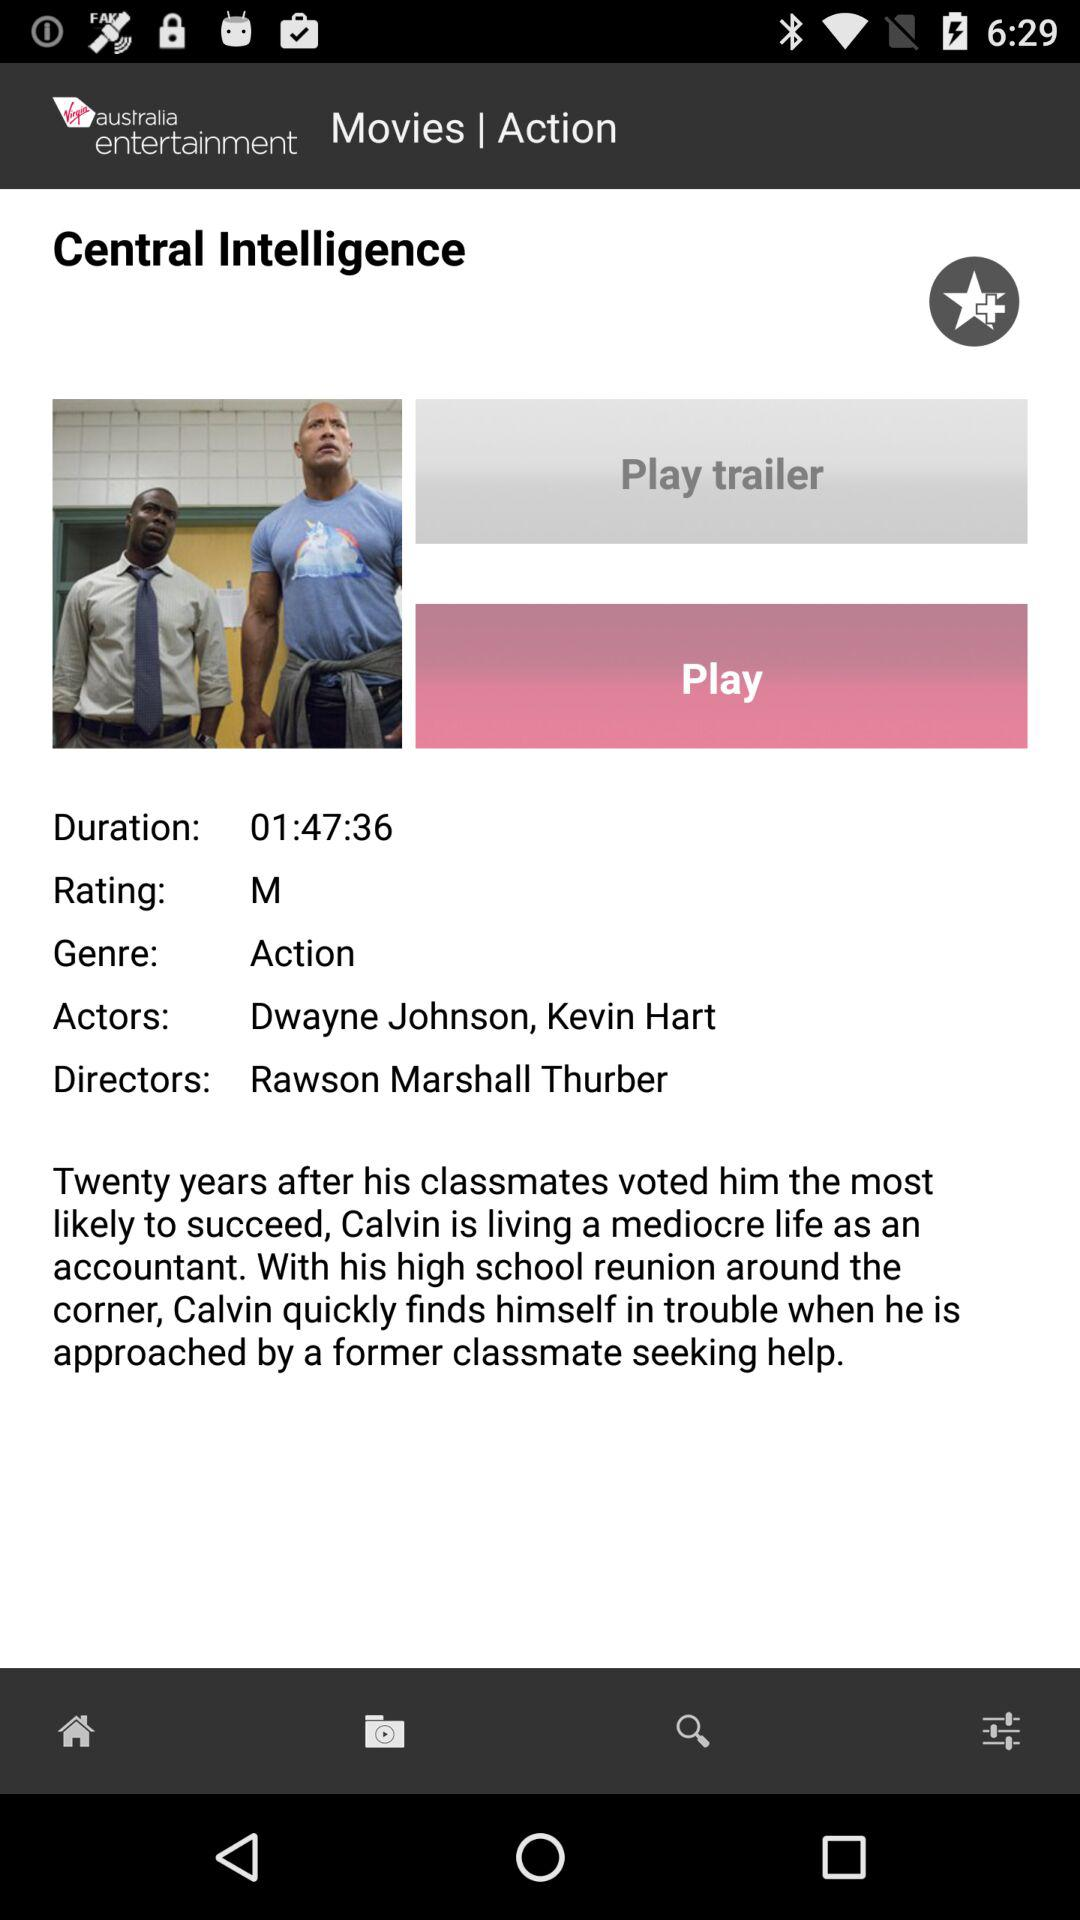What are the names of the actors? The names of the actors are Dwayne Johnson and Kevin Hart. 